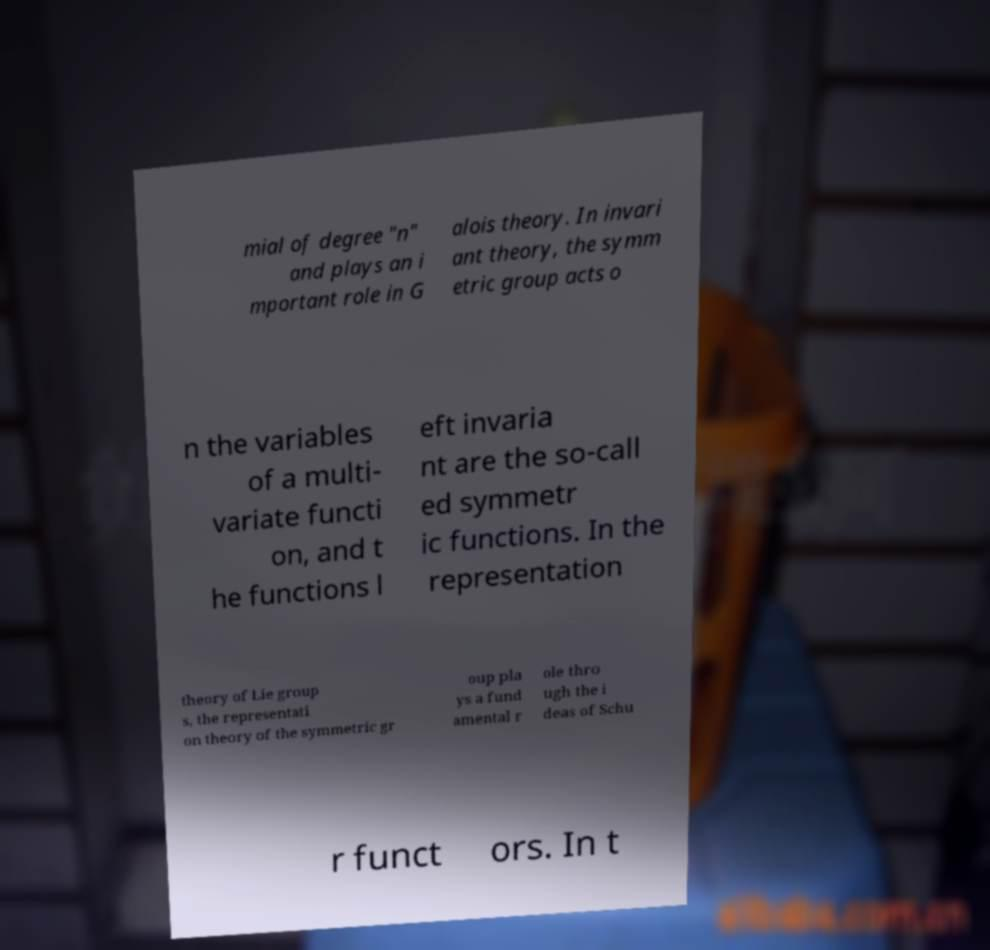Could you assist in decoding the text presented in this image and type it out clearly? mial of degree "n" and plays an i mportant role in G alois theory. In invari ant theory, the symm etric group acts o n the variables of a multi- variate functi on, and t he functions l eft invaria nt are the so-call ed symmetr ic functions. In the representation theory of Lie group s, the representati on theory of the symmetric gr oup pla ys a fund amental r ole thro ugh the i deas of Schu r funct ors. In t 